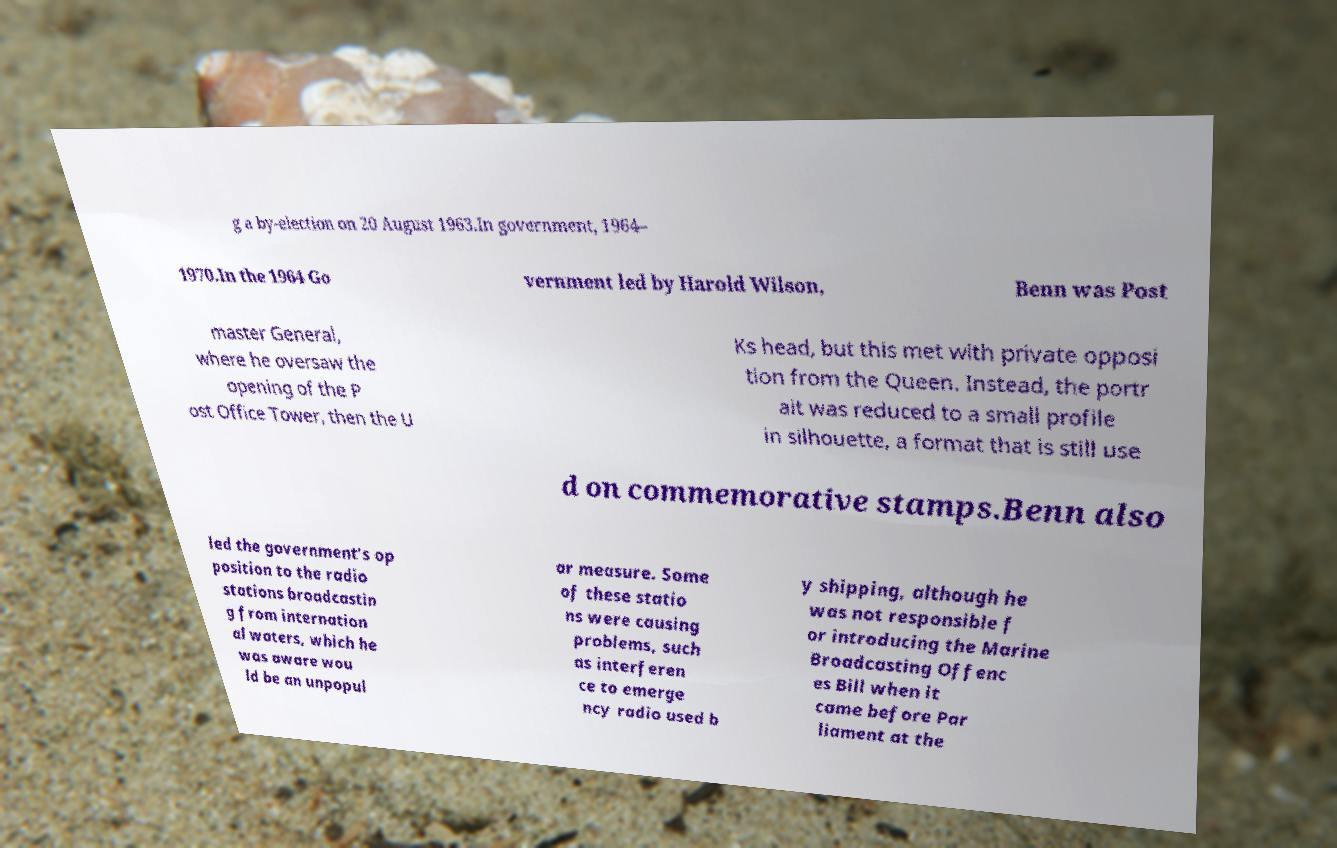There's text embedded in this image that I need extracted. Can you transcribe it verbatim? g a by-election on 20 August 1963.In government, 1964– 1970.In the 1964 Go vernment led by Harold Wilson, Benn was Post master General, where he oversaw the opening of the P ost Office Tower, then the U Ks head, but this met with private opposi tion from the Queen. Instead, the portr ait was reduced to a small profile in silhouette, a format that is still use d on commemorative stamps.Benn also led the government's op position to the radio stations broadcastin g from internation al waters, which he was aware wou ld be an unpopul ar measure. Some of these statio ns were causing problems, such as interferen ce to emerge ncy radio used b y shipping, although he was not responsible f or introducing the Marine Broadcasting Offenc es Bill when it came before Par liament at the 